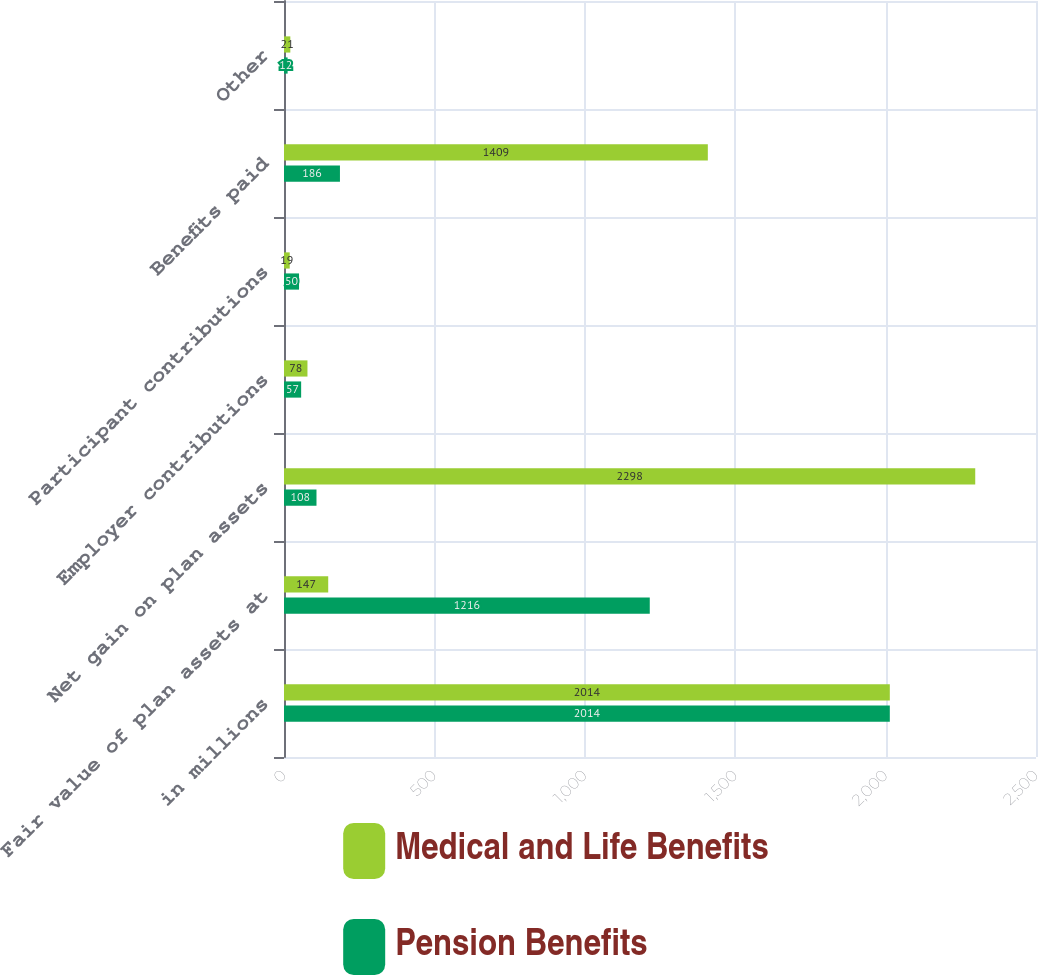<chart> <loc_0><loc_0><loc_500><loc_500><stacked_bar_chart><ecel><fcel>in millions<fcel>Fair value of plan assets at<fcel>Net gain on plan assets<fcel>Employer contributions<fcel>Participant contributions<fcel>Benefits paid<fcel>Other<nl><fcel>Medical and Life Benefits<fcel>2014<fcel>147<fcel>2298<fcel>78<fcel>19<fcel>1409<fcel>21<nl><fcel>Pension Benefits<fcel>2014<fcel>1216<fcel>108<fcel>57<fcel>50<fcel>186<fcel>12<nl></chart> 